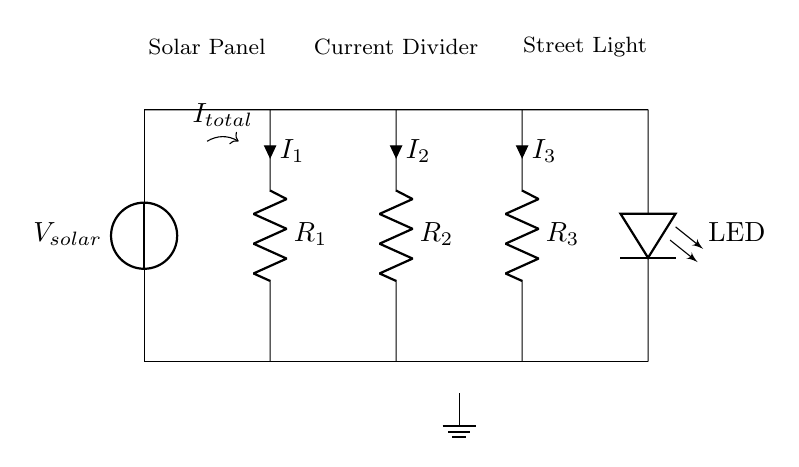What is the total current entering the current divider? The total current entering the current divider is indicated as I total, which is shown above the solar panel in the circuit diagram.
Answer: I total What type of components are R1, R2, and R3? R1, R2, and R3 are resistors, as identified by the 'R' label next to each component in the diagram.
Answer: Resistors How many branches are in the current divider? The current divider has three branches, each containing a resistor that divides the total current into separate paths for I1, I2, and I3.
Answer: Three What is the purpose of the LED in this circuit? The LED functions as the street light, converting the electrical energy from the current into light for illumination in the urban environment.
Answer: Street light If R1 has a resistance of 10 ohms and R2 has a resistance of 20 ohms, which resistor would carry more current? To find which resistor carries more current, you apply the current divider rule, which states that the current through a resistor is inversely proportional to its resistance. Since R1 is lower in value than R2, it will carry more current.
Answer: R1 What do the labels I1, I2, and I3 represent? I1, I2, and I3 represent the currents flowing through resistors R1, R2, and R3 respectively, as indicated by the arrows next to each resistor in the diagram.
Answer: Currents through R1, R2, and R3 